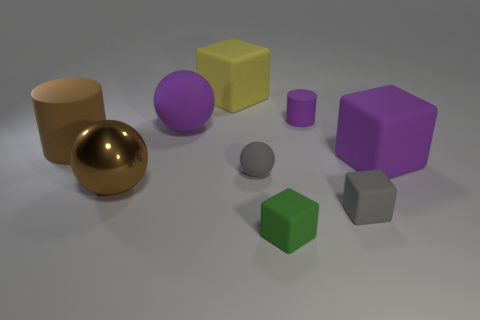Subtract all blue cylinders. Subtract all blue spheres. How many cylinders are left? 2 Add 1 tiny green cylinders. How many objects exist? 10 Subtract all cylinders. How many objects are left? 7 Subtract all red spheres. Subtract all small matte blocks. How many objects are left? 7 Add 5 gray rubber things. How many gray rubber things are left? 7 Add 2 yellow things. How many yellow things exist? 3 Subtract 0 cyan cubes. How many objects are left? 9 